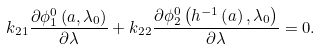<formula> <loc_0><loc_0><loc_500><loc_500>k _ { 2 1 } \frac { \partial \phi _ { 1 } ^ { 0 } \left ( a , \lambda _ { 0 } \right ) } { \partial \lambda } + k _ { 2 2 } \frac { \partial \phi _ { 2 } ^ { 0 } \left ( h ^ { - 1 } \left ( a \right ) , \lambda _ { 0 } \right ) } { \partial \lambda } = 0 .</formula> 